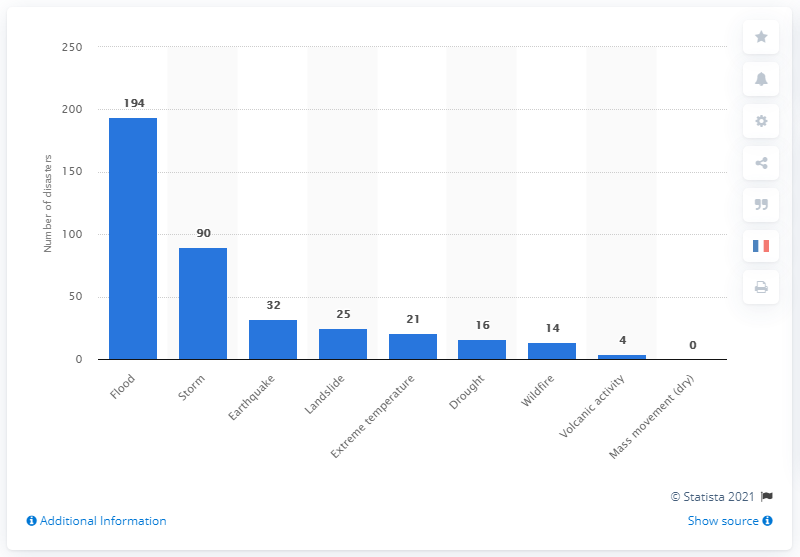Point out several critical features in this image. There were 194 floods in 2019. 